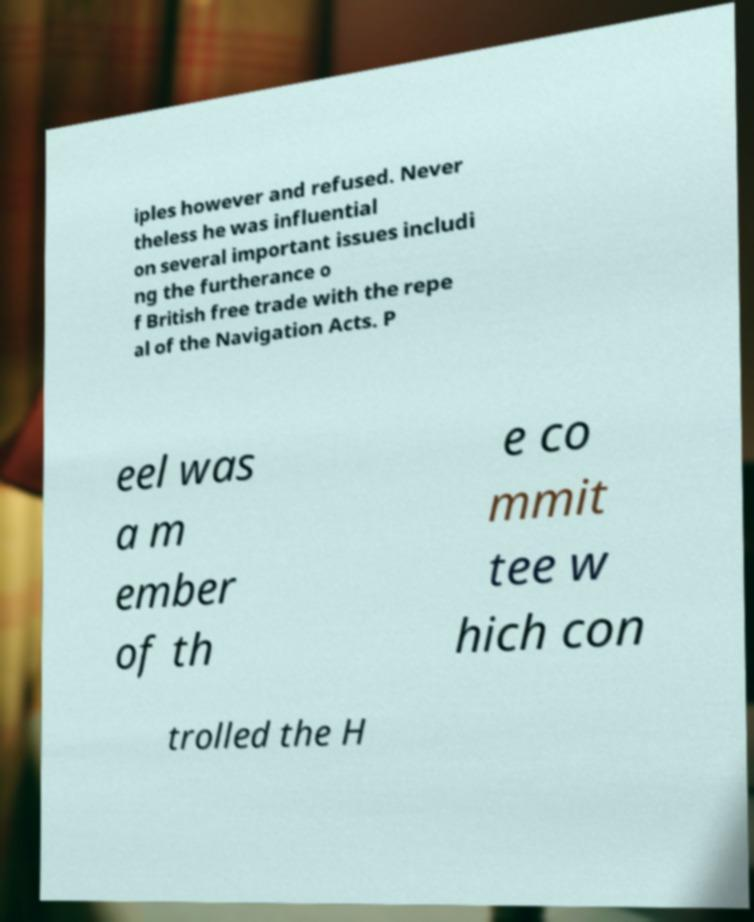For documentation purposes, I need the text within this image transcribed. Could you provide that? iples however and refused. Never theless he was influential on several important issues includi ng the furtherance o f British free trade with the repe al of the Navigation Acts. P eel was a m ember of th e co mmit tee w hich con trolled the H 